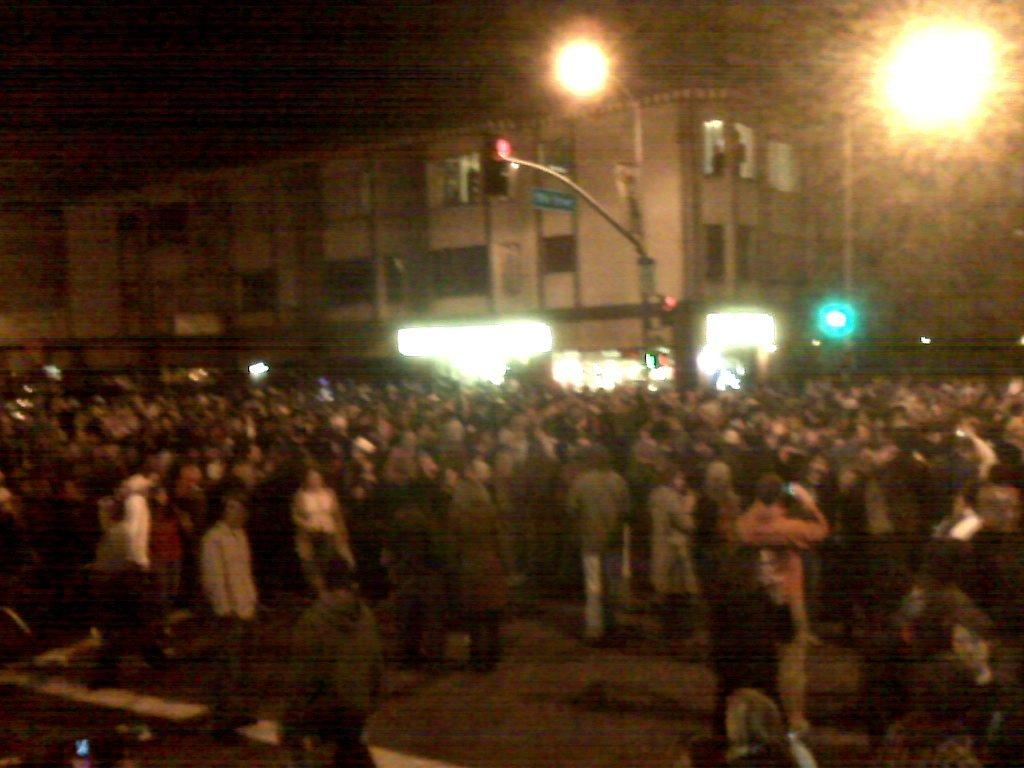How many people are in the image? There is a group of people in the image, but the exact number is not specified. What can be observed about the clothing of the people in the image? The people are wearing different color dresses. What can be seen in the background of the image? There are boards, poles, a building, and lights in the background of the image. What is the color of the background in the image? The background of the image is black. What type of liquid is being served at the party in the image? There is no party present in the image, and therefore no liquid being served. What mathematical operation is being performed on the addition sign in the image? There is no addition sign present in the image. 